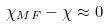Convert formula to latex. <formula><loc_0><loc_0><loc_500><loc_500>\chi _ { M F } - \chi \approx 0</formula> 